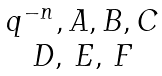<formula> <loc_0><loc_0><loc_500><loc_500>\begin{matrix} q ^ { - n } , A , B , C \\ D , \, E , \, F \end{matrix}</formula> 